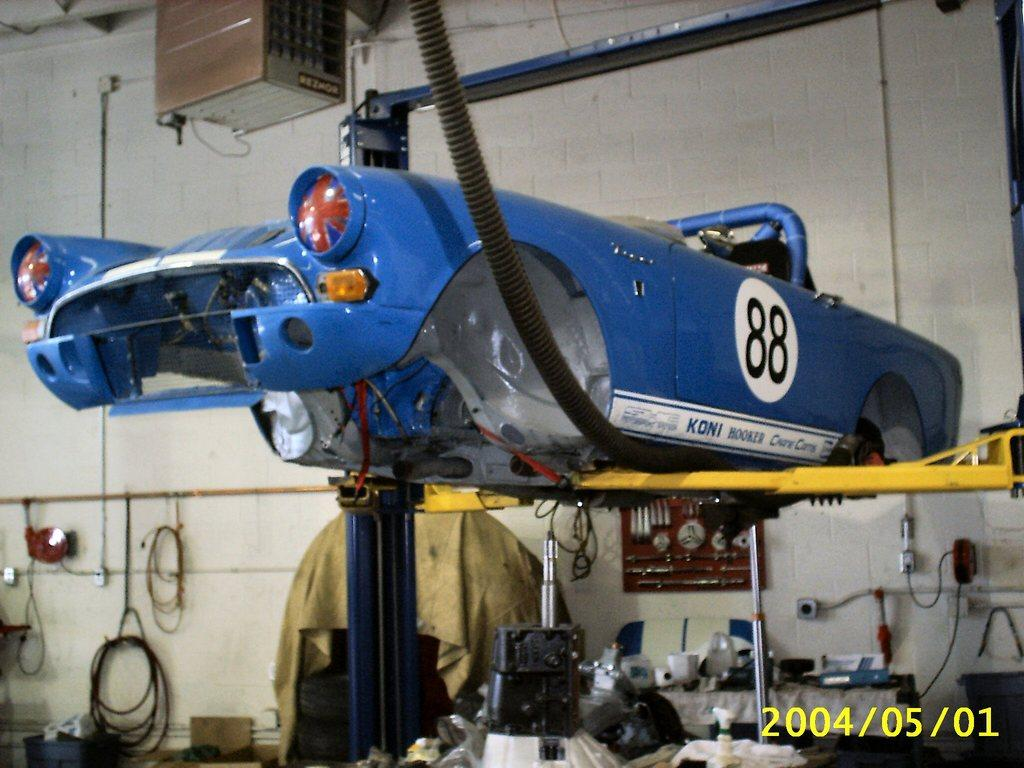<image>
Provide a brief description of the given image. Blue vehicle with the number 88 on it's side is at a car shop. 